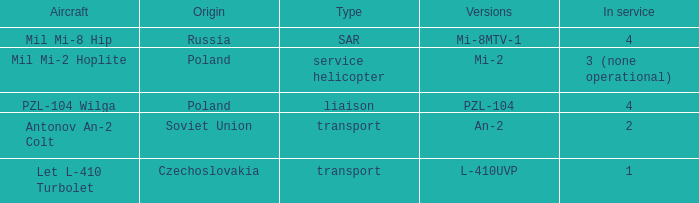Tell me the service for versions l-410uvp 1.0. 